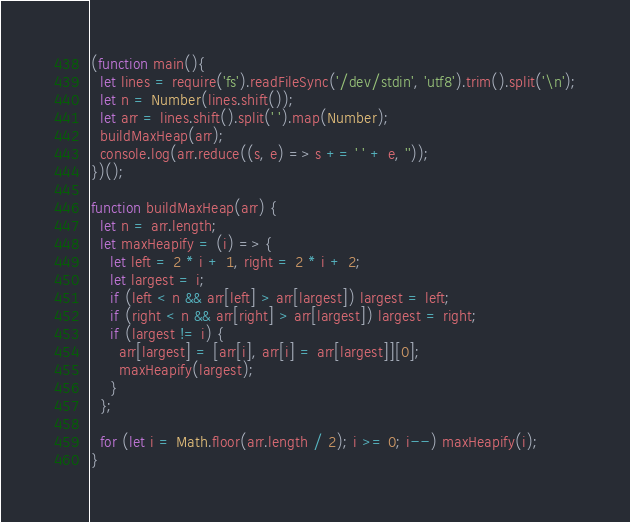Convert code to text. <code><loc_0><loc_0><loc_500><loc_500><_JavaScript_>(function main(){
  let lines = require('fs').readFileSync('/dev/stdin', 'utf8').trim().split('\n');
  let n = Number(lines.shift());
  let arr = lines.shift().split(' ').map(Number);
  buildMaxHeap(arr);
  console.log(arr.reduce((s, e) => s += ' ' + e, ''));
})();

function buildMaxHeap(arr) {
  let n = arr.length;
  let maxHeapify = (i) => {
    let left = 2 * i + 1, right = 2 * i + 2;
    let largest = i;
    if (left < n && arr[left] > arr[largest]) largest = left;
    if (right < n && arr[right] > arr[largest]) largest = right;
    if (largest != i) {
      arr[largest] = [arr[i], arr[i] = arr[largest]][0];
      maxHeapify(largest);
    }
  };

  for (let i = Math.floor(arr.length / 2); i >= 0; i--) maxHeapify(i);
}

</code> 